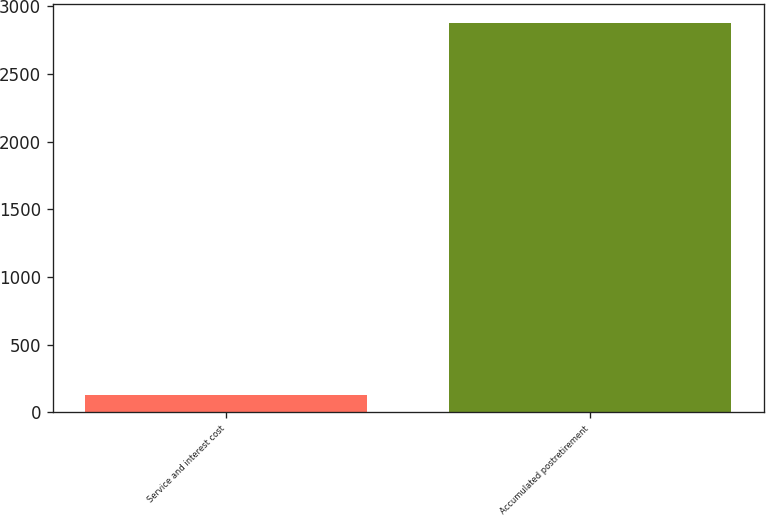Convert chart. <chart><loc_0><loc_0><loc_500><loc_500><bar_chart><fcel>Service and interest cost<fcel>Accumulated postretirement<nl><fcel>128<fcel>2876<nl></chart> 